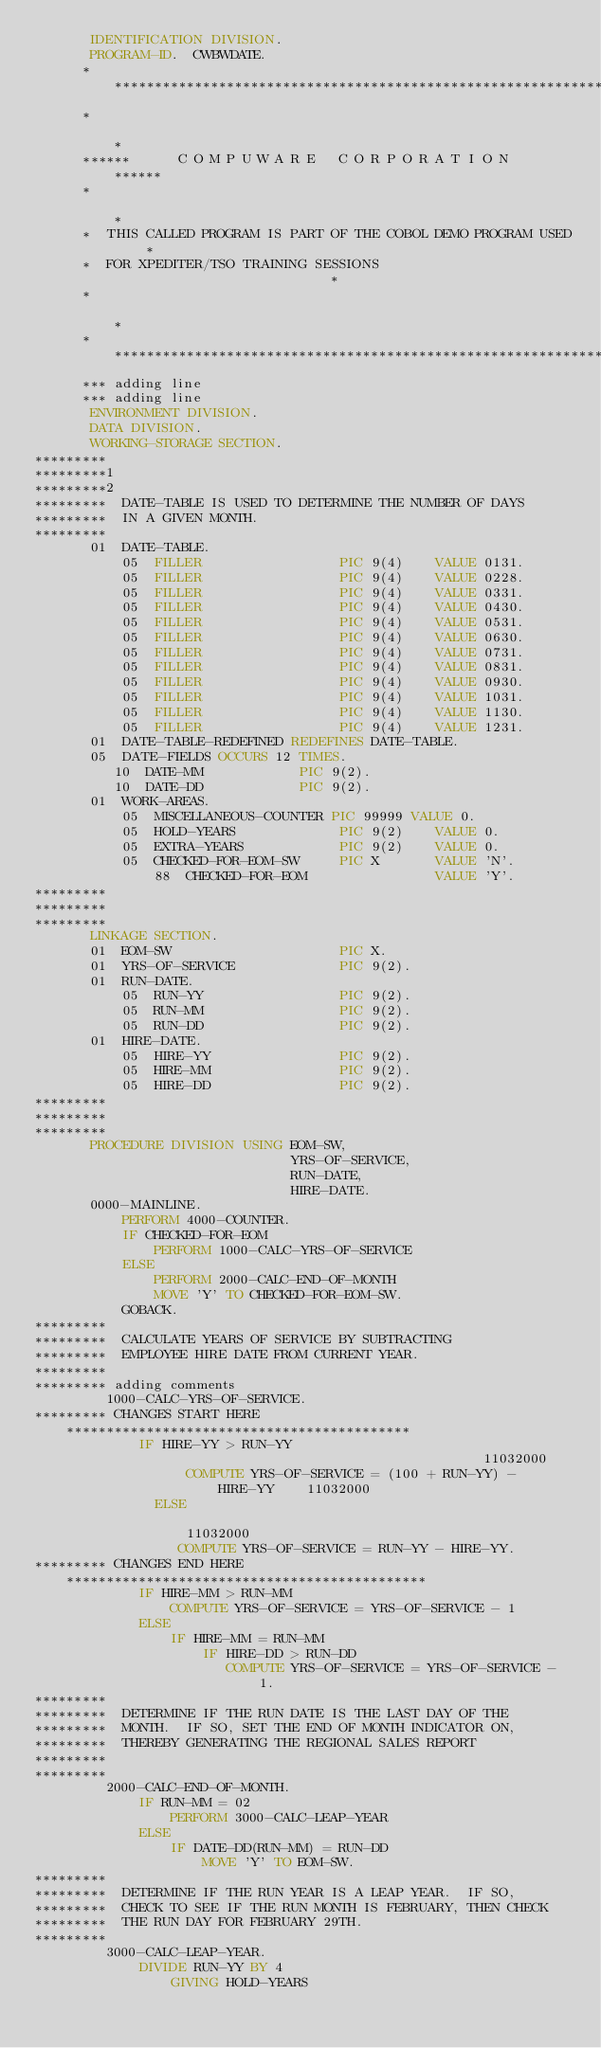<code> <loc_0><loc_0><loc_500><loc_500><_COBOL_>       IDENTIFICATION DIVISION.
       PROGRAM-ID.  CWBWDATE.
      ******************************************************************
      *                                                                *
      ******      C O M P U W A R E   C O R P O R A T I O N       ******
      *                                                                *
      *  THIS CALLED PROGRAM IS PART OF THE COBOL DEMO PROGRAM USED    *
      *  FOR XPEDITER/TSO TRAINING SESSIONS                            *
      *                                                                *
      ******************************************************************
      *** adding line
      *** adding line
       ENVIRONMENT DIVISION.
       DATA DIVISION.
       WORKING-STORAGE SECTION.
*********
*********1
*********2
*********  DATE-TABLE IS USED TO DETERMINE THE NUMBER OF DAYS
*********  IN A GIVEN MONTH.
*********
       01  DATE-TABLE.
           05  FILLER                 PIC 9(4)    VALUE 0131.
           05  FILLER                 PIC 9(4)    VALUE 0228.
           05  FILLER                 PIC 9(4)    VALUE 0331.
           05  FILLER                 PIC 9(4)    VALUE 0430.
           05  FILLER                 PIC 9(4)    VALUE 0531.
           05  FILLER                 PIC 9(4)    VALUE 0630.
           05  FILLER                 PIC 9(4)    VALUE 0731.
           05  FILLER                 PIC 9(4)    VALUE 0831.
           05  FILLER                 PIC 9(4)    VALUE 0930.
           05  FILLER                 PIC 9(4)    VALUE 1031.
           05  FILLER                 PIC 9(4)    VALUE 1130.
           05  FILLER                 PIC 9(4)    VALUE 1231.
       01  DATE-TABLE-REDEFINED REDEFINES DATE-TABLE.
       05  DATE-FIELDS OCCURS 12 TIMES.
          10  DATE-MM            PIC 9(2).
          10  DATE-DD            PIC 9(2).
       01  WORK-AREAS.
           05  MISCELLANEOUS-COUNTER PIC 99999 VALUE 0.
           05  HOLD-YEARS             PIC 9(2)    VALUE 0.
           05  EXTRA-YEARS            PIC 9(2)    VALUE 0.
           05  CHECKED-FOR-EOM-SW     PIC X       VALUE 'N'.
               88  CHECKED-FOR-EOM                VALUE 'Y'.
*********
*********
*********
       LINKAGE SECTION.
       01  EOM-SW                     PIC X.
       01  YRS-OF-SERVICE             PIC 9(2).
       01  RUN-DATE.
           05  RUN-YY                 PIC 9(2).
           05  RUN-MM                 PIC 9(2).
           05  RUN-DD                 PIC 9(2).
       01  HIRE-DATE.
           05  HIRE-YY                PIC 9(2).
           05  HIRE-MM                PIC 9(2).
           05  HIRE-DD                PIC 9(2).
*********
*********
*********
       PROCEDURE DIVISION USING EOM-SW,
                                YRS-OF-SERVICE,
                                RUN-DATE,
                                HIRE-DATE.
       0000-MAINLINE.
           PERFORM 4000-COUNTER.
           IF CHECKED-FOR-EOM
               PERFORM 1000-CALC-YRS-OF-SERVICE
           ELSE
               PERFORM 2000-CALC-END-OF-MONTH
               MOVE 'Y' TO CHECKED-FOR-EOM-SW.
           GOBACK.
*********
*********  CALCULATE YEARS OF SERVICE BY SUBTRACTING
*********  EMPLOYEE HIRE DATE FROM CURRENT YEAR.
*********
********* adding comments
         1000-CALC-YRS-OF-SERVICE.
********* CHANGES START HERE *******************************************
             IF HIRE-YY > RUN-YY                                        11032000
                   COMPUTE YRS-OF-SERVICE = (100 + RUN-YY) - HIRE-YY    11032000
               ELSE                                                     11032000
                  COMPUTE YRS-OF-SERVICE = RUN-YY - HIRE-YY.
********* CHANGES END HERE *********************************************
             IF HIRE-MM > RUN-MM
                 COMPUTE YRS-OF-SERVICE = YRS-OF-SERVICE - 1
             ELSE
                 IF HIRE-MM = RUN-MM
                     IF HIRE-DD > RUN-DD
                        COMPUTE YRS-OF-SERVICE = YRS-OF-SERVICE - 1.
*********
*********  DETERMINE IF THE RUN DATE IS THE LAST DAY OF THE
*********  MONTH.  IF SO, SET THE END OF MONTH INDICATOR ON,
*********  THEREBY GENERATING THE REGIONAL SALES REPORT
*********
*********
         2000-CALC-END-OF-MONTH.
             IF RUN-MM = 02
                 PERFORM 3000-CALC-LEAP-YEAR
             ELSE
                 IF DATE-DD(RUN-MM) = RUN-DD
                     MOVE 'Y' TO EOM-SW.
*********
*********  DETERMINE IF THE RUN YEAR IS A LEAP YEAR.  IF SO,
*********  CHECK TO SEE IF THE RUN MONTH IS FEBRUARY, THEN CHECK
*********  THE RUN DAY FOR FEBRUARY 29TH.
*********
         3000-CALC-LEAP-YEAR.
             DIVIDE RUN-YY BY 4
                 GIVING HOLD-YEARS</code> 